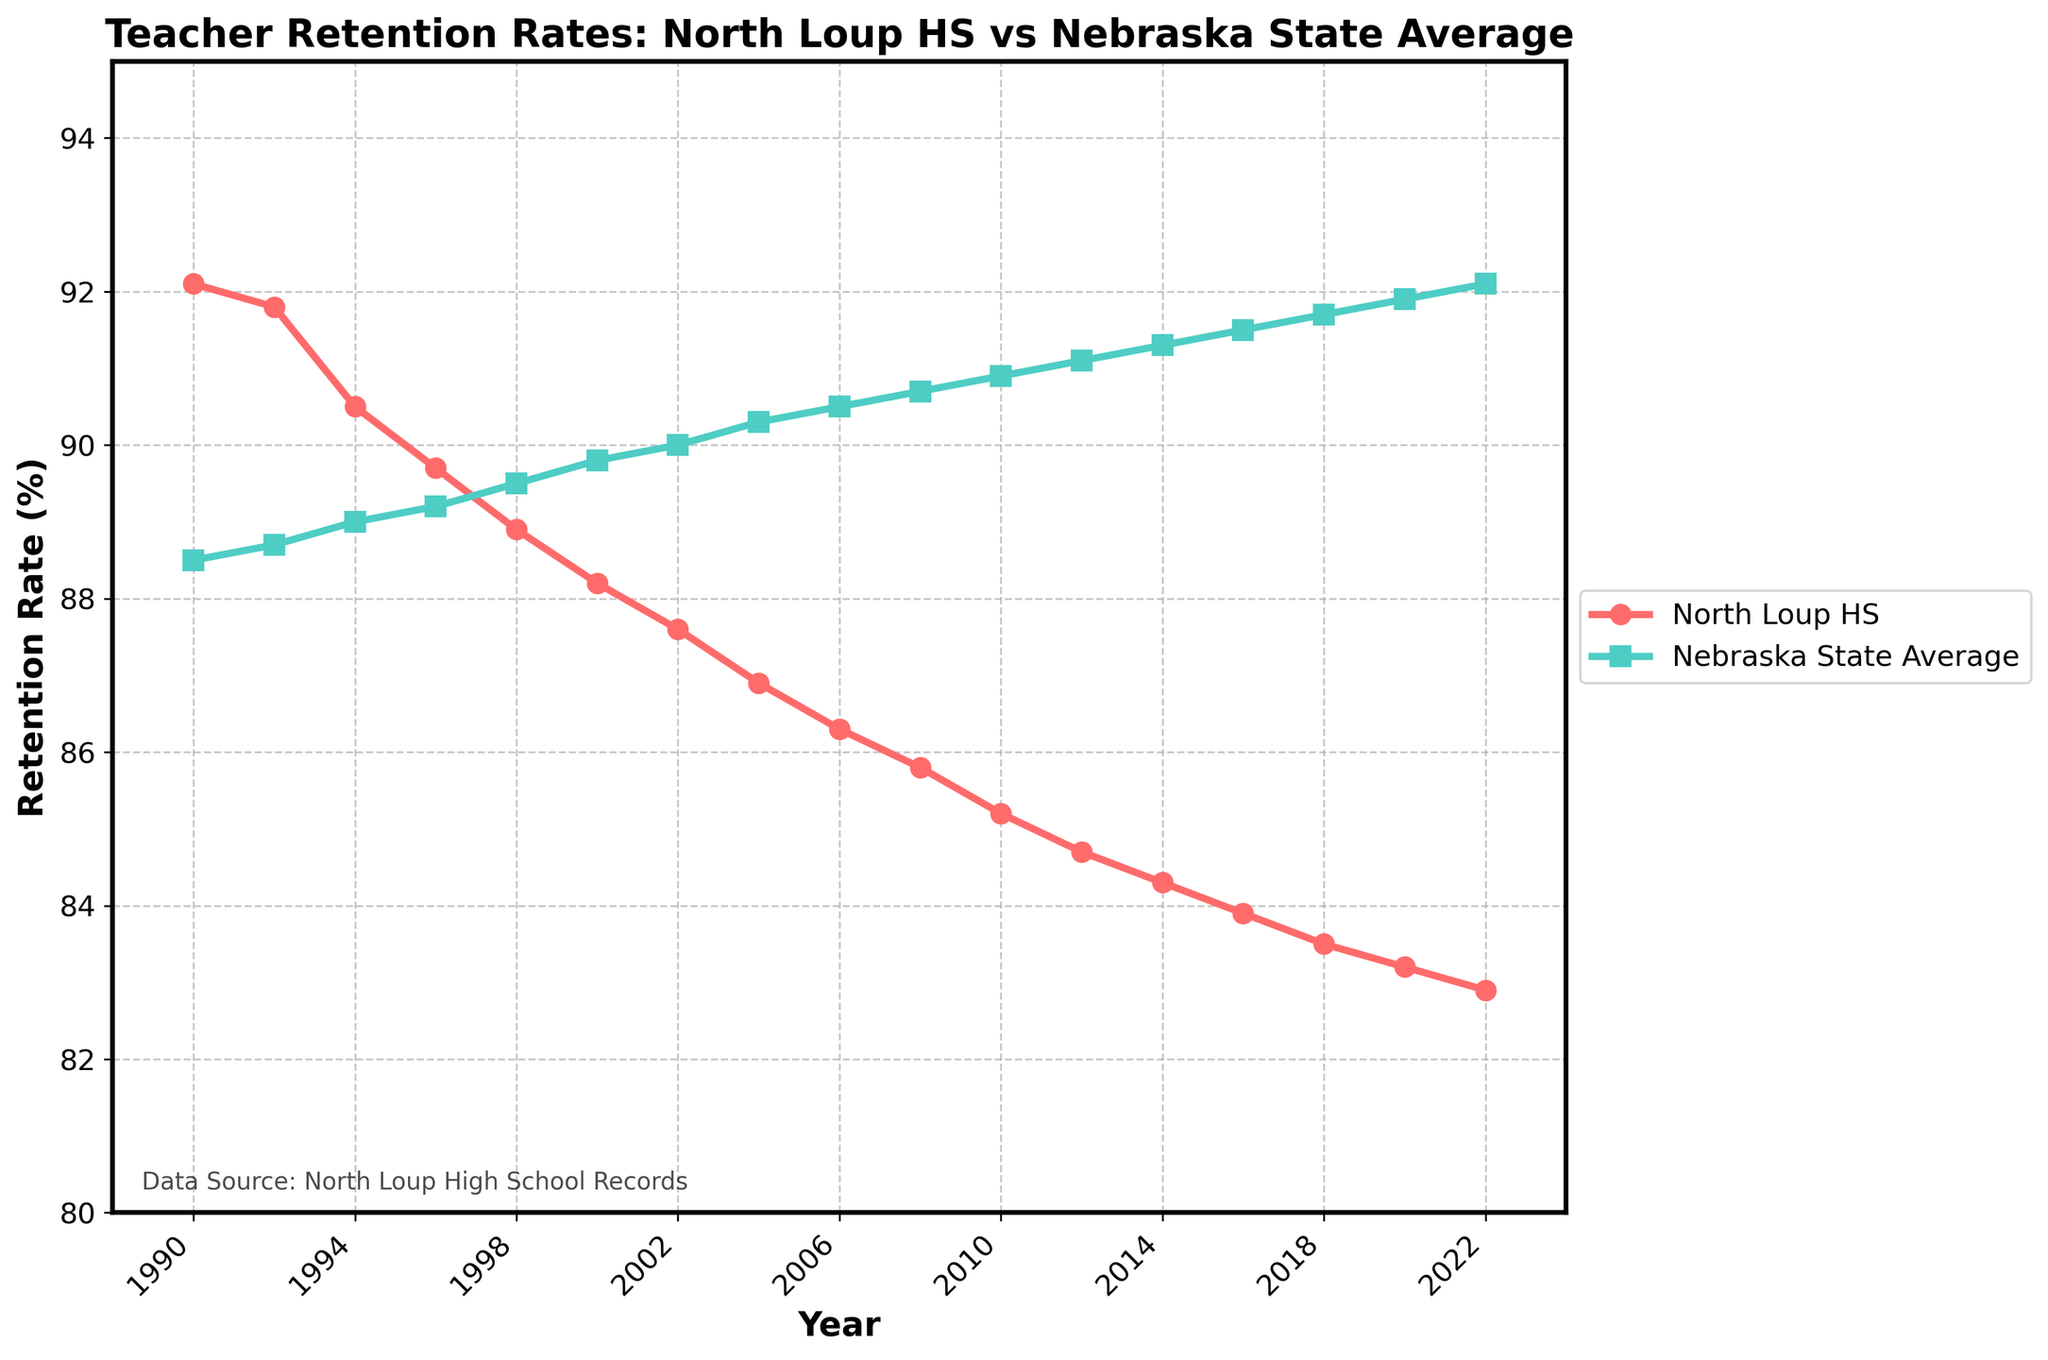How has the retention rate at North Loup High School changed from 1990 to 2022? By observing the red line representing North Loup HS in the plot, it can be seen that the retention rate has steadily declined from 92.1% in 1990 to 82.9% in 2022.
Answer: Declined from 92.1% to 82.9% In which year did the Nebraska state average retention rate surpass 90%? By looking at the turquoise line representing the Nebraska State Average, it surpassed 90% for the first time in 2002, where the state average retention rate increased to exactly 90.0%.
Answer: 2002 What is the difference in retention rates between North Loup High School and the Nebraska state average in 2022? For 2022, the retention rate at North Loup HS is 82.9% while the Nebraska state average is 92.1%. The difference between these rates is 92.1% - 82.9% = 9.2%.
Answer: 9.2% What trend can be observed in the Nebraska state average retention rate from 1990 to 2022? Observing the turquoise line representing Nebraska State Average, it shows a generally increasing trend from 88.5% in 1990 to 92.1% in 2022.
Answer: Increasing trend Comparing 1996 and 2004, how did the retention rate change for North Loup High School, and how did it change for the Nebraska state average? In 1996, North Loup HS had a retention rate of 89.7%, which decreased to 86.9% by 2004. For the state average, it went from 89.2% in 1996 to 90.3% in 2004. North Loup HS decreased by 2.8% whereas the state average increased by 1.1%.
Answer: North Loup HS decreased by 2.8%, State average increased by 1.1% 